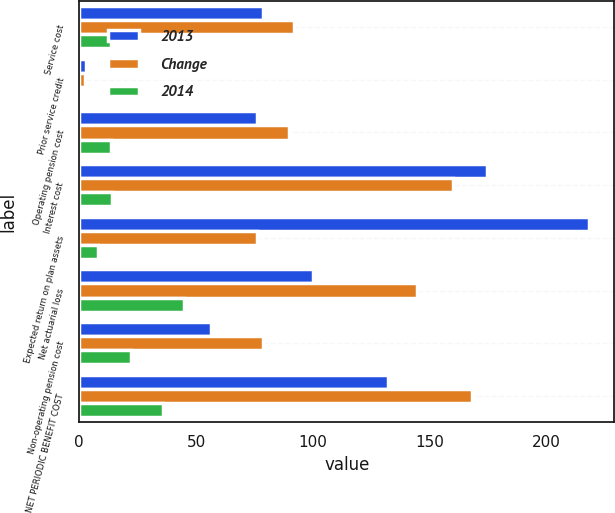Convert chart. <chart><loc_0><loc_0><loc_500><loc_500><stacked_bar_chart><ecel><fcel>Service cost<fcel>Prior service credit<fcel>Operating pension cost<fcel>Interest cost<fcel>Expected return on plan assets<fcel>Net actuarial loss<fcel>Non-operating pension cost<fcel>NET PERIODIC BENEFIT COST<nl><fcel>2013<fcel>78.7<fcel>2.7<fcel>76<fcel>174.4<fcel>218.1<fcel>99.9<fcel>56.2<fcel>132.2<nl><fcel>Change<fcel>92.1<fcel>2.5<fcel>89.6<fcel>160.2<fcel>76<fcel>144.6<fcel>78.5<fcel>168.1<nl><fcel>2014<fcel>13.4<fcel>0.2<fcel>13.6<fcel>14.2<fcel>8.2<fcel>44.7<fcel>22.3<fcel>35.9<nl></chart> 